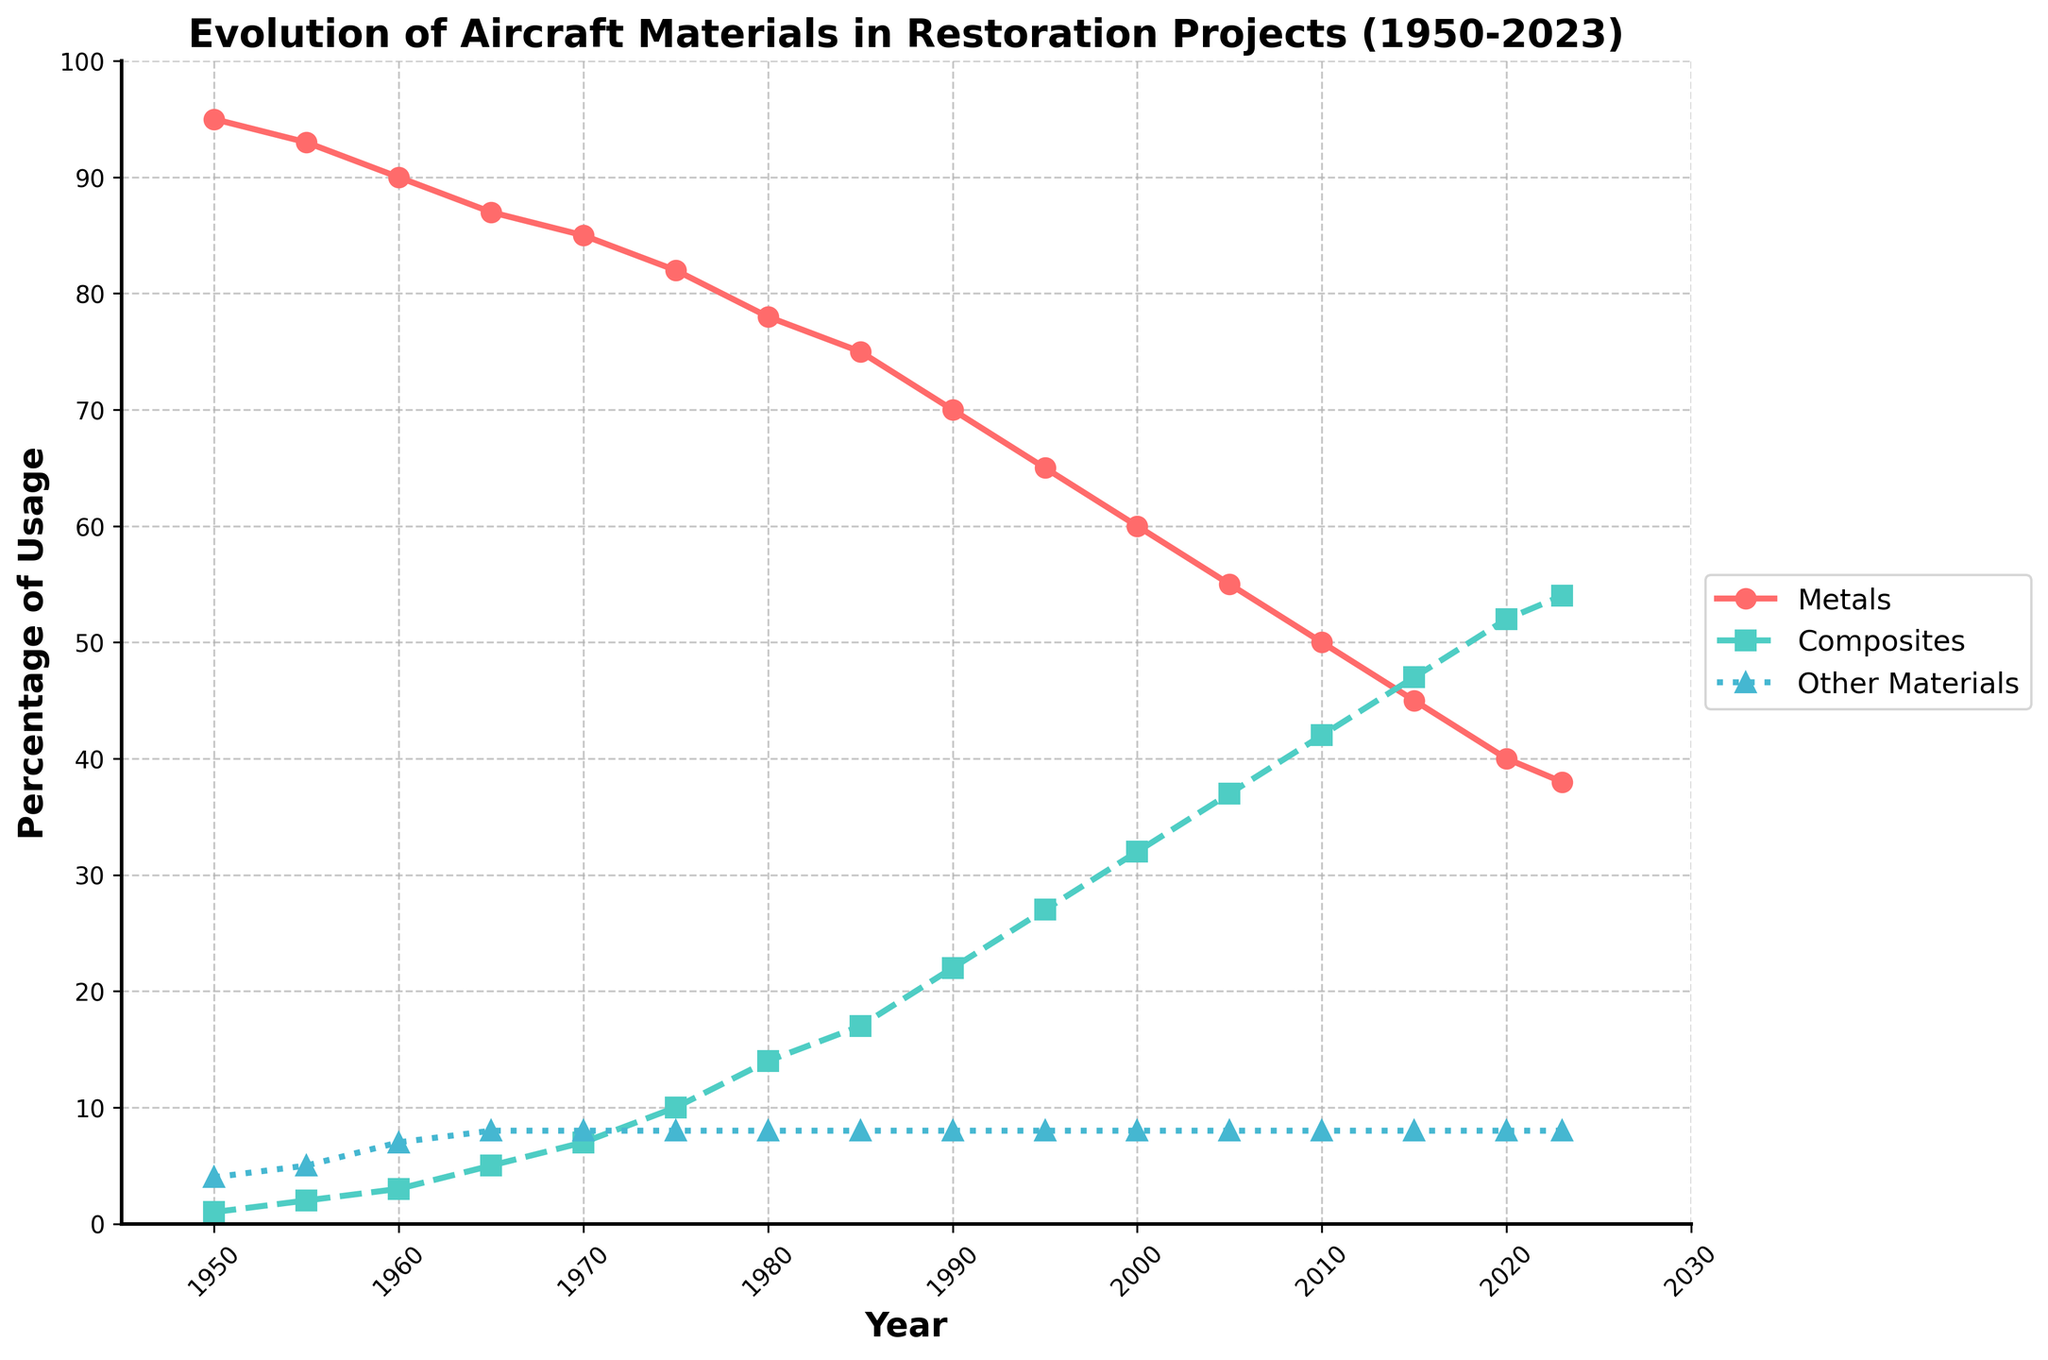What is the trend in the usage percentage of metals from 1950 to 2023? The trend for metals shows a consistent decline from 95% in 1950 to 38% in 2023. This indicates a steady decrease in the reliance on metals over the years.
Answer: Decreasing In what year did the usage of composites surpass 20%? Looking at the line plot for composites, the usage percentage surpasses 20% in 1990.
Answer: 1990 Which material type had the least variation in its usage percentage from 1950 to 2023? Observing the line plots, "Other Materials" remains nearly constant at 8% from 1965 onwards with minor changes before that period, indicating the least variation compared to metals and composites.
Answer: Other Materials How much did the usage of composites increase from 1950 to 2023? The usage of composites increased from 1% in 1950 to 54% in 2023. The total increase is 54% - 1% = 53%.
Answer: 53% How do the usage percentages of metals and composites compare in 2010? In 2010, the percentage for metals is around 50% while composites are around 42%. Metals have the higher usage percentage compared to composites in 2010.
Answer: Metals higher What is the combined percentage of metals and other materials in 2000? In 2000, metals account for 60% and other materials account for 8%. Thus, the combined percentage is 60% + 8% = 68%.
Answer: 68% At which year do metals and composites have the closest usage percentage? The closest values appear visually around 2015, where metals are at 45% and composites are at 47%, a difference of only 2%.
Answer: 2015 What decade saw the greatest reduction in the percentage usage of metals? Observing the decades, the greatest reduction occurs between 1990 and 2000 where the usage declines from 70% to 60%, marking a 10% reduction.
Answer: 1990-2000 What is the slope of the line for composites between 1950 and 1970? The line for composites starts at 1% in 1950 and reaches 7% in 1970. The slope is calculated as (7% - 1%) / (1970 - 1950) = 6% / 20 years = 0.3% per year.
Answer: 0.3% per year Which material saw its usage percentage double first, composites or other materials? Composite usage doubles first, rising from 1% in 1950 to 2% by 1955.
Answer: Composites 